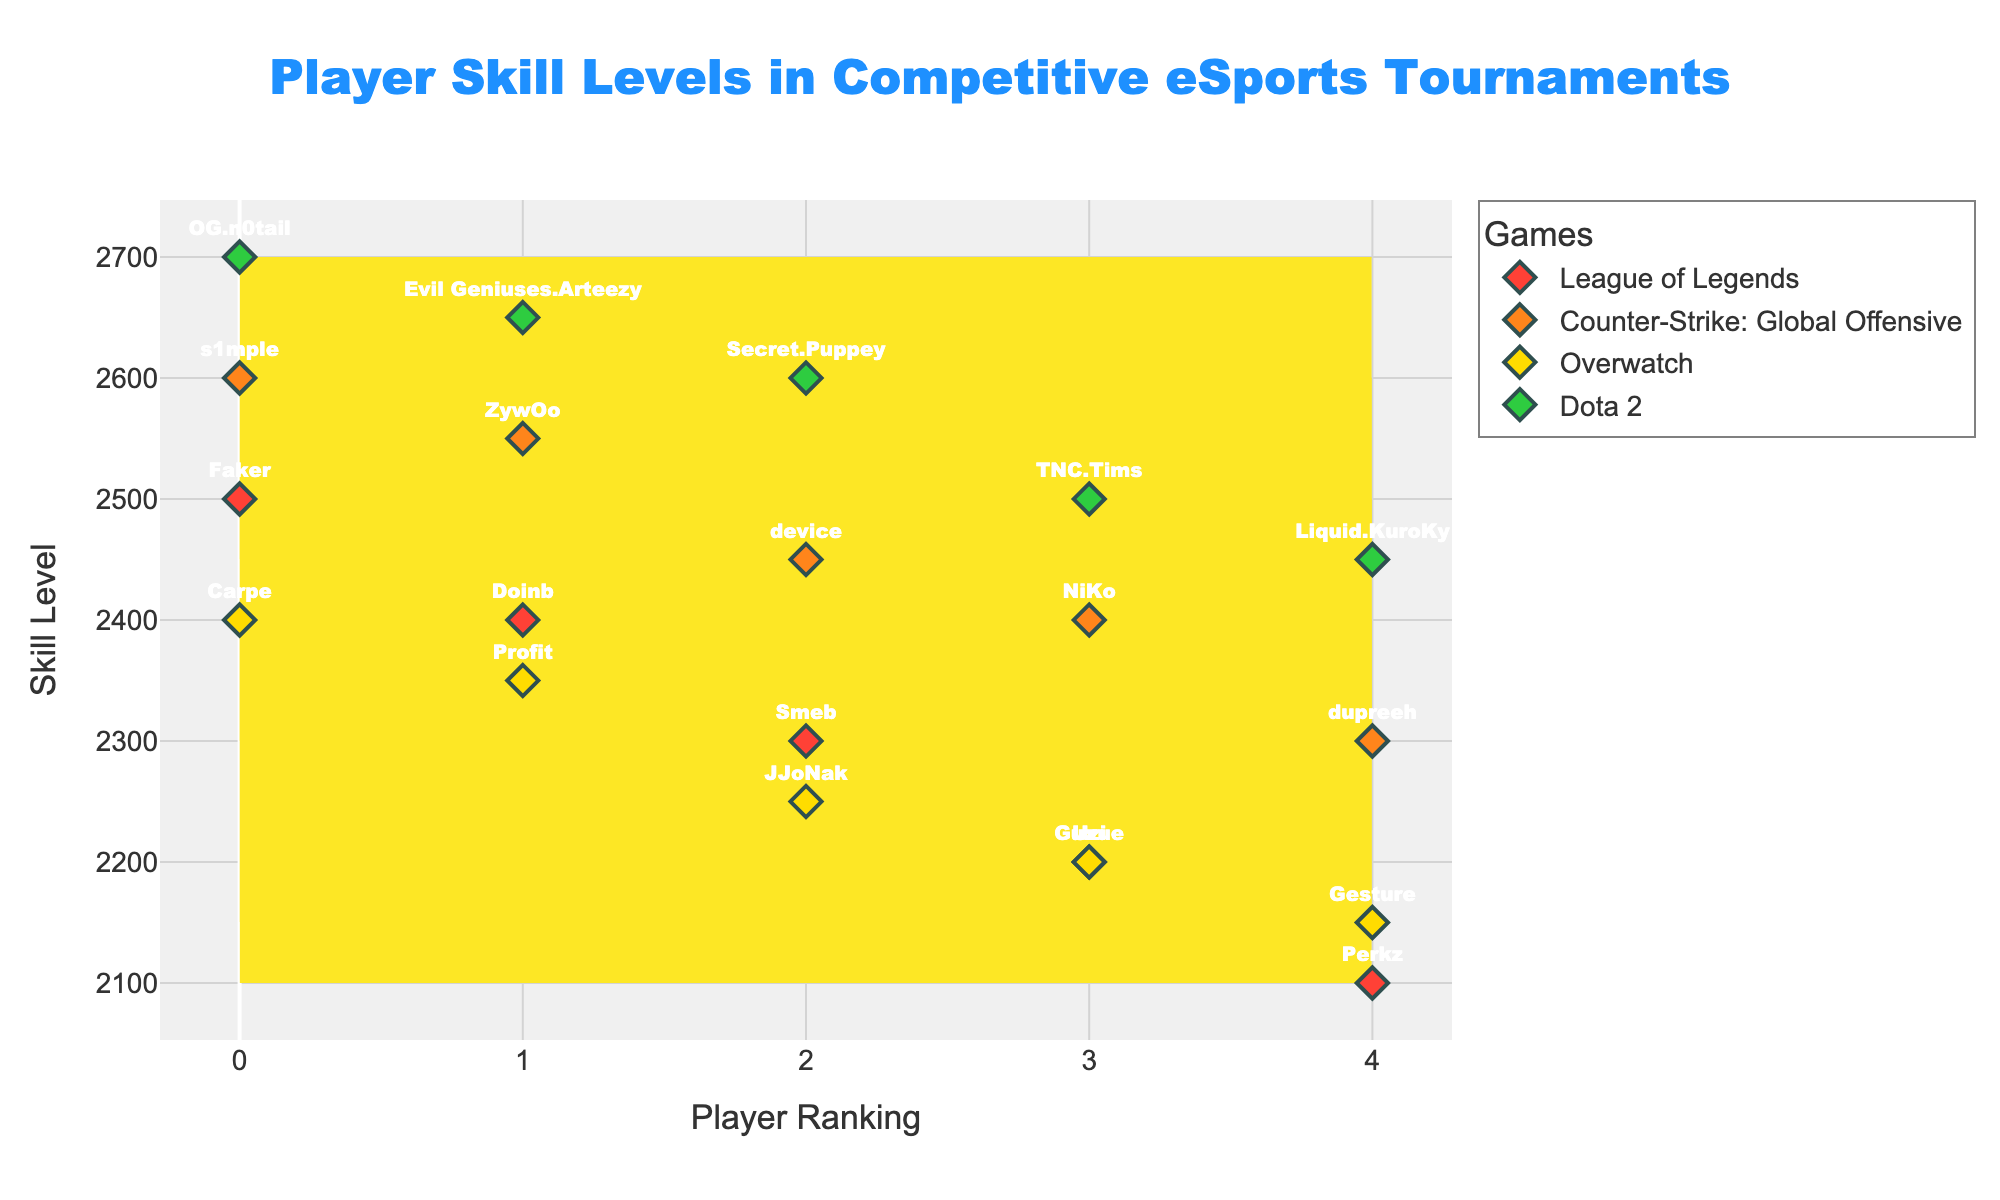What is the title of the figure? The title is usually displayed prominently at the top of the figure. In this case, it indicates what the figure is about.
Answer: Player Skill Levels in Competitive eSports Tournaments How many unique games are represented in the plot? By examining the different colored contours and markers, one can identify the unique games represented in the plot. The color legend aids in this identification.
Answer: 4 Which player has the highest skill level in Dota 2? The Dota 2 markers are likely colored green, and we can see the labels. The player with the highest y-value among these markers has the highest skill level.
Answer: OG.n0tail What is the skill level range shown for Overwatch? The skill levels of Overwatch players can be identified by looking at the yellow markers and noting the minimum and maximum values on the y-axis.
Answer: 2150 to 2400 Who is the highest skilled player in Counter-Strike: Global Offensive? The orange markers represent Counter-Strike: Global Offensive players. The highest y-value among these markers indicates the highest skilled player.
Answer: s1mple Which game features the player with the highest skill level in the plot? By observing the y-axis for all markers, the player with the highest y-value can be identified, and the corresponding game color/type can be noted.
Answer: Dota 2 How many players have a skill level below 2300 in the plot? Count the number of markers for all games that lie below the y-axis value of 2300.
Answer: 7 